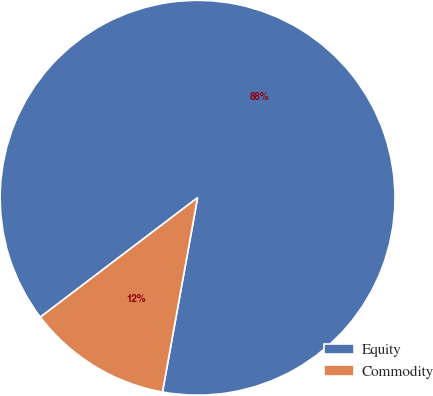Convert chart. <chart><loc_0><loc_0><loc_500><loc_500><pie_chart><fcel>Equity<fcel>Commodity<nl><fcel>88.18%<fcel>11.82%<nl></chart> 